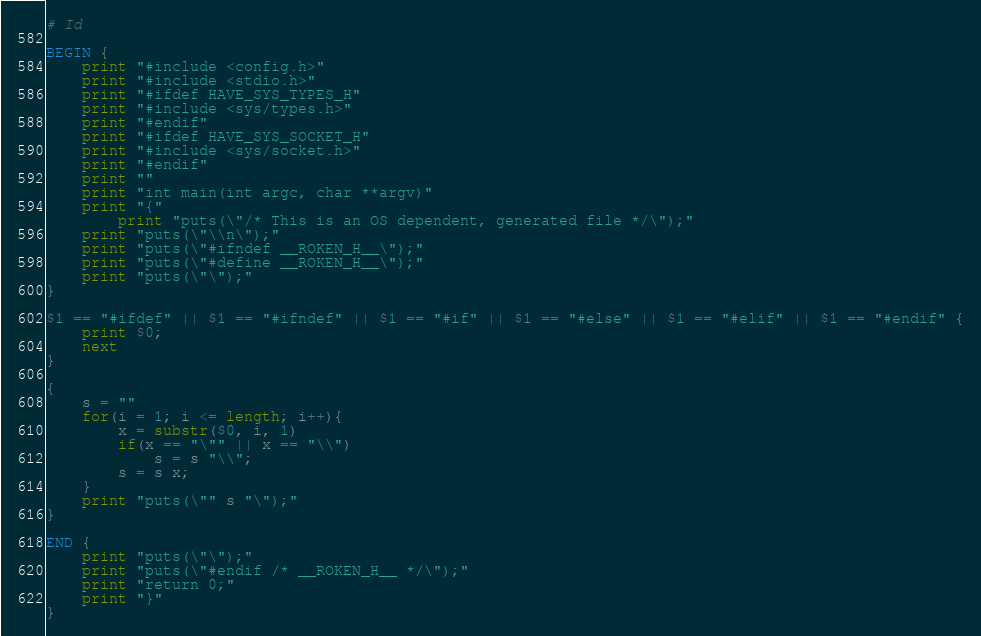Convert code to text. <code><loc_0><loc_0><loc_500><loc_500><_Awk_># Id

BEGIN {
	print "#include <config.h>"
	print "#include <stdio.h>"
	print "#ifdef HAVE_SYS_TYPES_H"
	print "#include <sys/types.h>"
	print "#endif"
	print "#ifdef HAVE_SYS_SOCKET_H"
	print "#include <sys/socket.h>"
	print "#endif"
	print ""
	print "int main(int argc, char **argv)"
	print "{"
	    print "puts(\"/* This is an OS dependent, generated file */\");"
	print "puts(\"\\n\");"
	print "puts(\"#ifndef __ROKEN_H__\");"
	print "puts(\"#define __ROKEN_H__\");"
	print "puts(\"\");"
}

$1 == "#ifdef" || $1 == "#ifndef" || $1 == "#if" || $1 == "#else" || $1 == "#elif" || $1 == "#endif" {
	print $0;
	next
}

{
	s = ""
	for(i = 1; i <= length; i++){
		x = substr($0, i, 1)
		if(x == "\"" || x == "\\")
			s = s "\\";
		s = s x;
	}
	print "puts(\"" s "\");"
}

END {
	print "puts(\"\");"
	print "puts(\"#endif /* __ROKEN_H__ */\");"
	print "return 0;"
	print "}"
}
</code> 